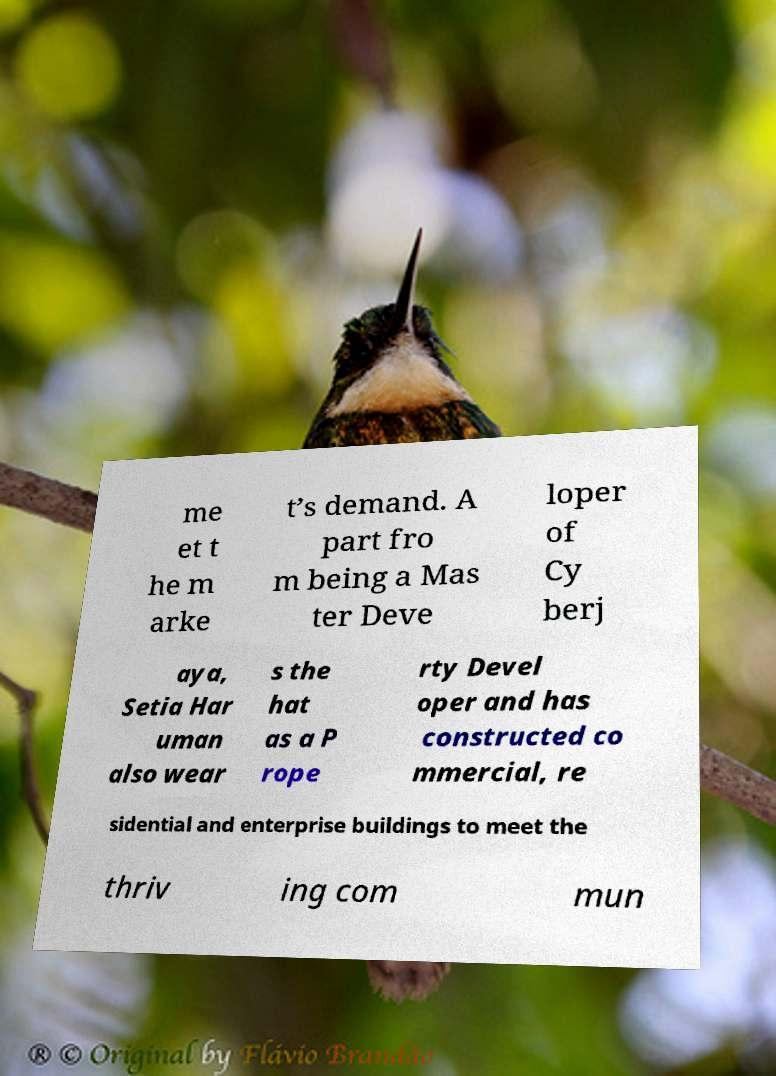Can you read and provide the text displayed in the image?This photo seems to have some interesting text. Can you extract and type it out for me? me et t he m arke t’s demand. A part fro m being a Mas ter Deve loper of Cy berj aya, Setia Har uman also wear s the hat as a P rope rty Devel oper and has constructed co mmercial, re sidential and enterprise buildings to meet the thriv ing com mun 